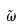Convert formula to latex. <formula><loc_0><loc_0><loc_500><loc_500>\tilde { \omega }</formula> 